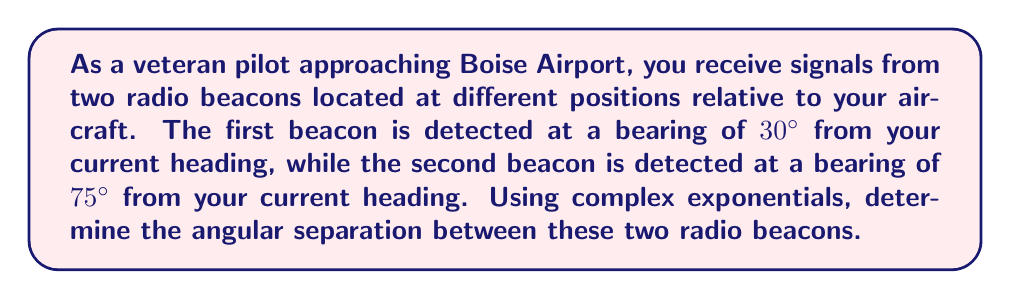What is the answer to this math problem? To solve this problem, we'll use complex exponentials to represent the directions of the radio beacons and then find the angle between them.

1) First, let's represent each beacon's direction as a complex exponential:
   
   Beacon 1: $e^{i\theta_1} = e^{i30°} = e^{i\frac{\pi}{6}}$
   Beacon 2: $e^{i\theta_2} = e^{i75°} = e^{i\frac{5\pi}{12}}$

2) The angular separation between the beacons is the argument (angle) of the quotient of these complex numbers:

   $\Delta\theta = \arg\left(\frac{e^{i\theta_2}}{e^{i\theta_1}}\right) = \arg(e^{i(\theta_2 - \theta_1)})$

3) Simplify the expression inside the parentheses:

   $e^{i(\theta_2 - \theta_1)} = e^{i(75° - 30°)} = e^{i45°} = e^{i\frac{\pi}{4}}$

4) The argument of $e^{i\frac{\pi}{4}}$ is simply $\frac{\pi}{4}$, which is the angular separation in radians.

5) Convert radians to degrees:

   $\frac{\pi}{4}$ radians = $45°$

Therefore, the angular separation between the two radio beacons is 45°.
Answer: The angular separation between the two radio beacons is 45°. 